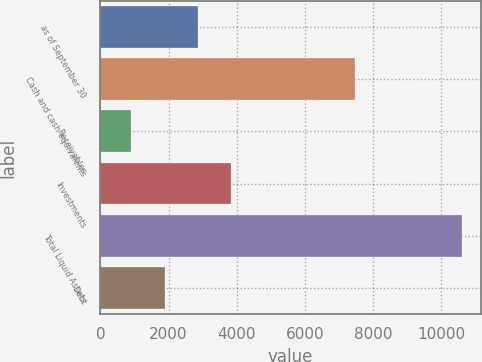<chart> <loc_0><loc_0><loc_500><loc_500><bar_chart><fcel>as of September 30<fcel>Cash and cash equivalents<fcel>Receivables<fcel>Investments<fcel>Total Liquid Assets<fcel>Debt<nl><fcel>2854<fcel>7476.8<fcel>910.8<fcel>3825.6<fcel>10626.8<fcel>1882.4<nl></chart> 